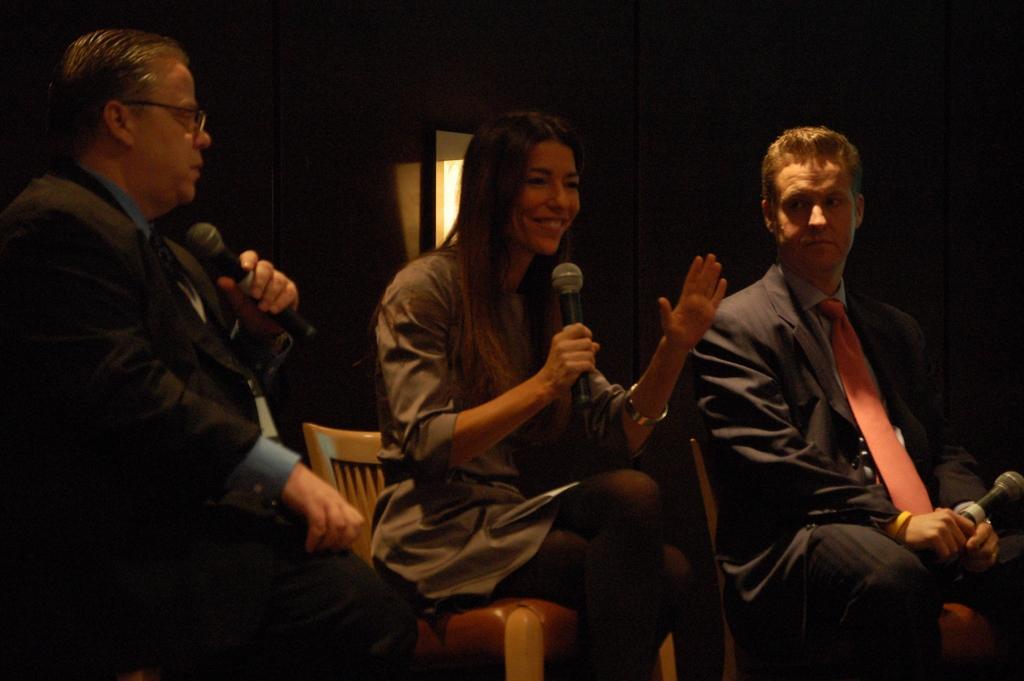Please provide a concise description of this image. In this image I can see three people are sitting on the chairs and holding mics. They are wearing different color dresses. Background is dark. 